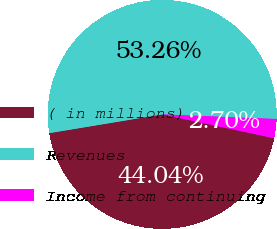Convert chart to OTSL. <chart><loc_0><loc_0><loc_500><loc_500><pie_chart><fcel>( in millions)<fcel>Revenues<fcel>Income from continuing<nl><fcel>44.04%<fcel>53.25%<fcel>2.7%<nl></chart> 